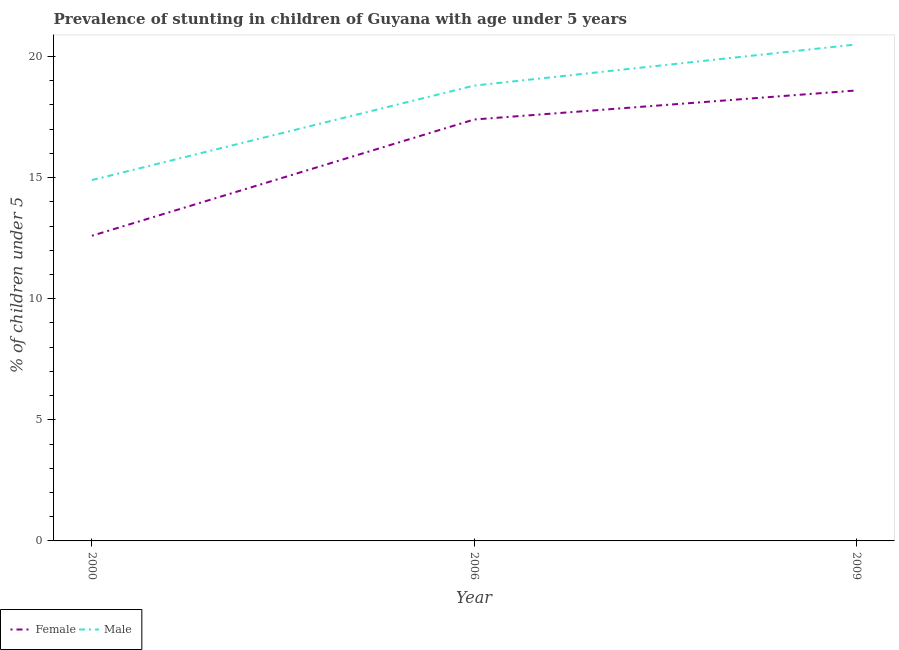How many different coloured lines are there?
Your response must be concise. 2. Is the number of lines equal to the number of legend labels?
Your answer should be very brief. Yes. What is the percentage of stunted female children in 2009?
Make the answer very short. 18.6. Across all years, what is the maximum percentage of stunted female children?
Ensure brevity in your answer.  18.6. Across all years, what is the minimum percentage of stunted male children?
Give a very brief answer. 14.9. In which year was the percentage of stunted female children maximum?
Provide a succinct answer. 2009. What is the total percentage of stunted male children in the graph?
Your response must be concise. 54.2. What is the difference between the percentage of stunted male children in 2006 and that in 2009?
Ensure brevity in your answer.  -1.7. What is the difference between the percentage of stunted female children in 2009 and the percentage of stunted male children in 2006?
Provide a short and direct response. -0.2. What is the average percentage of stunted male children per year?
Your answer should be very brief. 18.07. In the year 2000, what is the difference between the percentage of stunted male children and percentage of stunted female children?
Your answer should be very brief. 2.3. In how many years, is the percentage of stunted male children greater than 3 %?
Make the answer very short. 3. What is the ratio of the percentage of stunted female children in 2000 to that in 2009?
Your answer should be very brief. 0.68. What is the difference between the highest and the second highest percentage of stunted male children?
Your answer should be compact. 1.7. What is the difference between the highest and the lowest percentage of stunted male children?
Offer a very short reply. 5.6. Does the percentage of stunted female children monotonically increase over the years?
Provide a short and direct response. Yes. Is the percentage of stunted female children strictly greater than the percentage of stunted male children over the years?
Offer a terse response. No. How many lines are there?
Keep it short and to the point. 2. How many years are there in the graph?
Keep it short and to the point. 3. What is the difference between two consecutive major ticks on the Y-axis?
Provide a succinct answer. 5. Are the values on the major ticks of Y-axis written in scientific E-notation?
Provide a short and direct response. No. How many legend labels are there?
Ensure brevity in your answer.  2. What is the title of the graph?
Your response must be concise. Prevalence of stunting in children of Guyana with age under 5 years. Does "National Tourists" appear as one of the legend labels in the graph?
Offer a terse response. No. What is the label or title of the Y-axis?
Provide a short and direct response.  % of children under 5. What is the  % of children under 5 of Female in 2000?
Keep it short and to the point. 12.6. What is the  % of children under 5 of Male in 2000?
Provide a succinct answer. 14.9. What is the  % of children under 5 of Female in 2006?
Provide a short and direct response. 17.4. What is the  % of children under 5 in Male in 2006?
Give a very brief answer. 18.8. What is the  % of children under 5 of Female in 2009?
Provide a succinct answer. 18.6. Across all years, what is the maximum  % of children under 5 in Female?
Ensure brevity in your answer.  18.6. Across all years, what is the maximum  % of children under 5 of Male?
Provide a short and direct response. 20.5. Across all years, what is the minimum  % of children under 5 in Female?
Provide a succinct answer. 12.6. Across all years, what is the minimum  % of children under 5 of Male?
Provide a succinct answer. 14.9. What is the total  % of children under 5 of Female in the graph?
Your answer should be very brief. 48.6. What is the total  % of children under 5 in Male in the graph?
Provide a succinct answer. 54.2. What is the difference between the  % of children under 5 of Female in 2000 and that in 2009?
Offer a terse response. -6. What is the difference between the  % of children under 5 in Female in 2006 and that in 2009?
Keep it short and to the point. -1.2. What is the difference between the  % of children under 5 in Female in 2006 and the  % of children under 5 in Male in 2009?
Offer a terse response. -3.1. What is the average  % of children under 5 of Male per year?
Your answer should be very brief. 18.07. In the year 2006, what is the difference between the  % of children under 5 in Female and  % of children under 5 in Male?
Ensure brevity in your answer.  -1.4. In the year 2009, what is the difference between the  % of children under 5 in Female and  % of children under 5 in Male?
Give a very brief answer. -1.9. What is the ratio of the  % of children under 5 in Female in 2000 to that in 2006?
Give a very brief answer. 0.72. What is the ratio of the  % of children under 5 of Male in 2000 to that in 2006?
Provide a short and direct response. 0.79. What is the ratio of the  % of children under 5 of Female in 2000 to that in 2009?
Offer a very short reply. 0.68. What is the ratio of the  % of children under 5 in Male in 2000 to that in 2009?
Offer a very short reply. 0.73. What is the ratio of the  % of children under 5 in Female in 2006 to that in 2009?
Provide a succinct answer. 0.94. What is the ratio of the  % of children under 5 in Male in 2006 to that in 2009?
Offer a terse response. 0.92. What is the difference between the highest and the second highest  % of children under 5 in Female?
Keep it short and to the point. 1.2. What is the difference between the highest and the second highest  % of children under 5 of Male?
Ensure brevity in your answer.  1.7. What is the difference between the highest and the lowest  % of children under 5 of Male?
Offer a terse response. 5.6. 